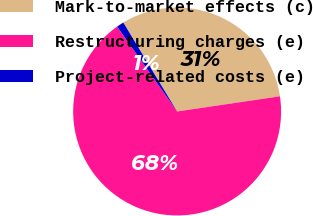Convert chart. <chart><loc_0><loc_0><loc_500><loc_500><pie_chart><fcel>Mark-to-market effects (c)<fcel>Restructuring charges (e)<fcel>Project-related costs (e)<nl><fcel>31.33%<fcel>67.54%<fcel>1.13%<nl></chart> 